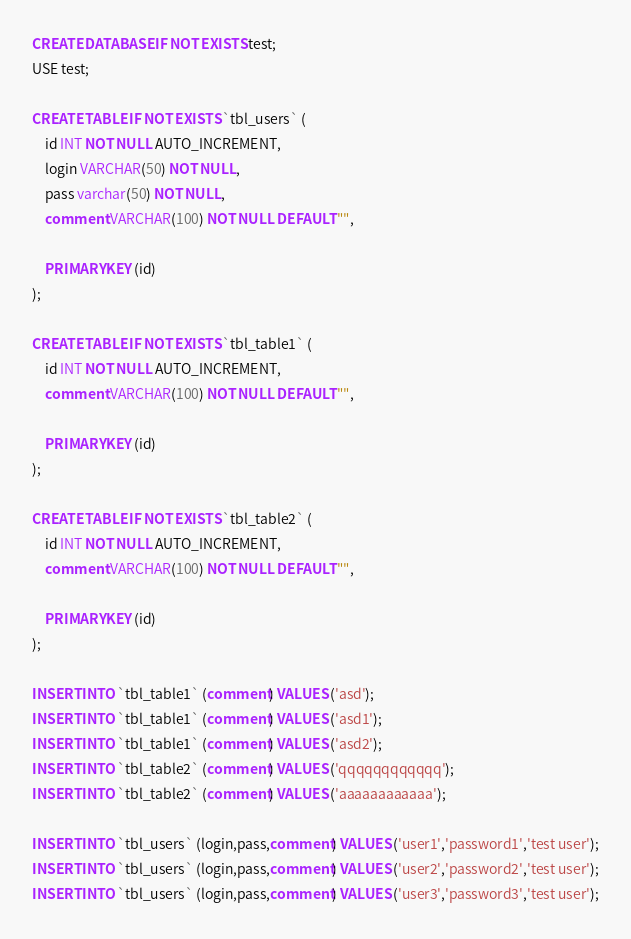<code> <loc_0><loc_0><loc_500><loc_500><_SQL_>CREATE DATABASE IF NOT EXISTS test;
USE test;

CREATE TABLE IF NOT EXISTS `tbl_users` (
    id INT NOT NULL AUTO_INCREMENT,
    login VARCHAR(50) NOT NULL,
    pass varchar(50) NOT NULL,
    comment VARCHAR(100) NOT NULL DEFAULT "",

    PRIMARY KEY (id)
);

CREATE TABLE IF NOT EXISTS `tbl_table1` (
    id INT NOT NULL AUTO_INCREMENT,
    comment VARCHAR(100) NOT NULL DEFAULT "",

    PRIMARY KEY (id)
);

CREATE TABLE IF NOT EXISTS `tbl_table2` (
    id INT NOT NULL AUTO_INCREMENT,
    comment VARCHAR(100) NOT NULL DEFAULT "",

    PRIMARY KEY (id)
);

INSERT INTO `tbl_table1` (comment) VALUES ('asd');
INSERT INTO `tbl_table1` (comment) VALUES ('asd1');
INSERT INTO `tbl_table1` (comment) VALUES ('asd2');
INSERT INTO `tbl_table2` (comment) VALUES ('qqqqqqqqqqqq');
INSERT INTO `tbl_table2` (comment) VALUES ('aaaaaaaaaaaa');

INSERT INTO `tbl_users` (login,pass,comment) VALUES ('user1','password1','test user');
INSERT INTO `tbl_users` (login,pass,comment) VALUES ('user2','password2','test user');
INSERT INTO `tbl_users` (login,pass,comment) VALUES ('user3','password3','test user');
</code> 